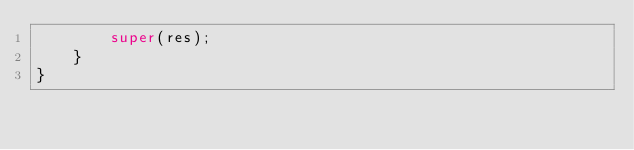Convert code to text. <code><loc_0><loc_0><loc_500><loc_500><_Java_>        super(res);
    }
}
</code> 